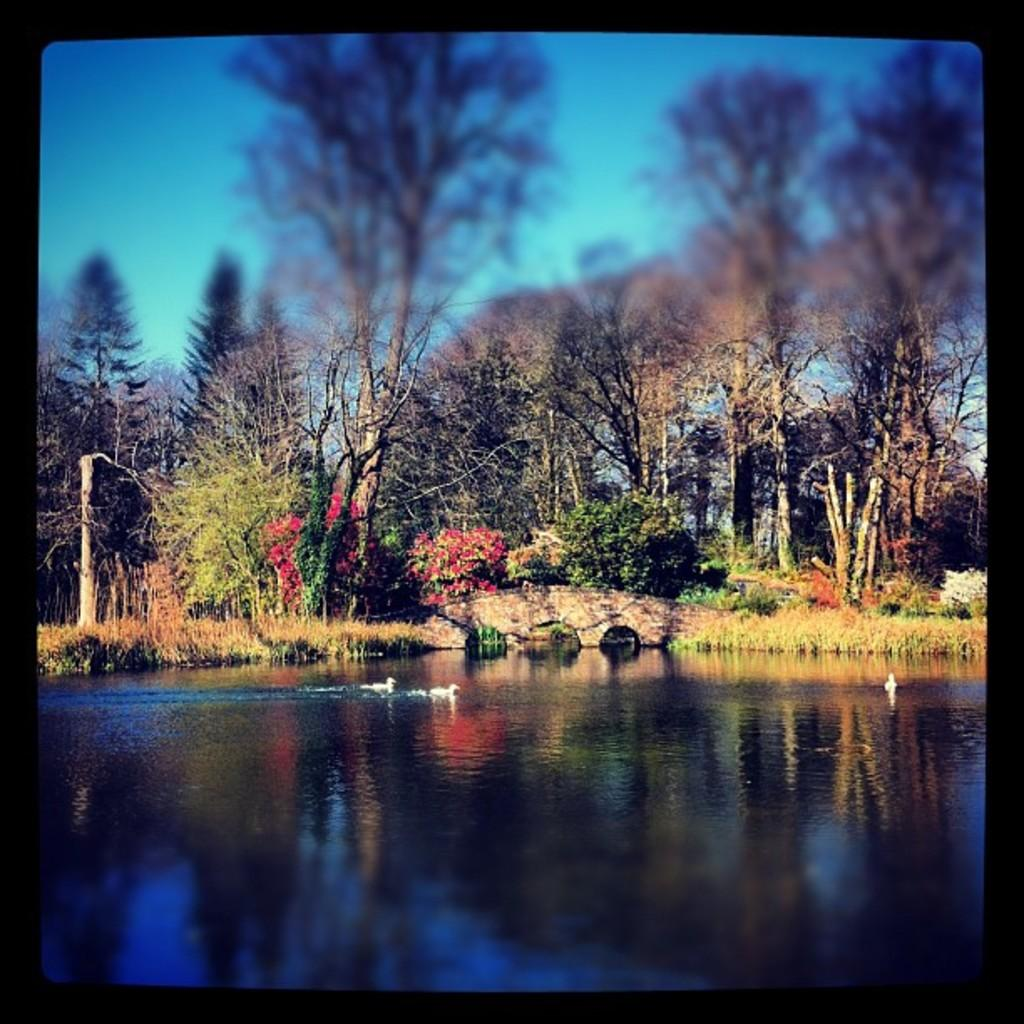What is the primary element in the image? There is water in the image. What type of animals can be seen in the image? Birds can be seen in the image. What type of vegetation is present in the image? There are plants, grass, flowers, and trees in the image. What can be seen in the background of the image? The sky is visible in the background of the image. What type of attraction is present in the image? There is no attraction present in the image; it features water, birds, plants, grass, flowers, trees, and the sky. What kind of cake can be seen in the image? There is no cake present in the image. 